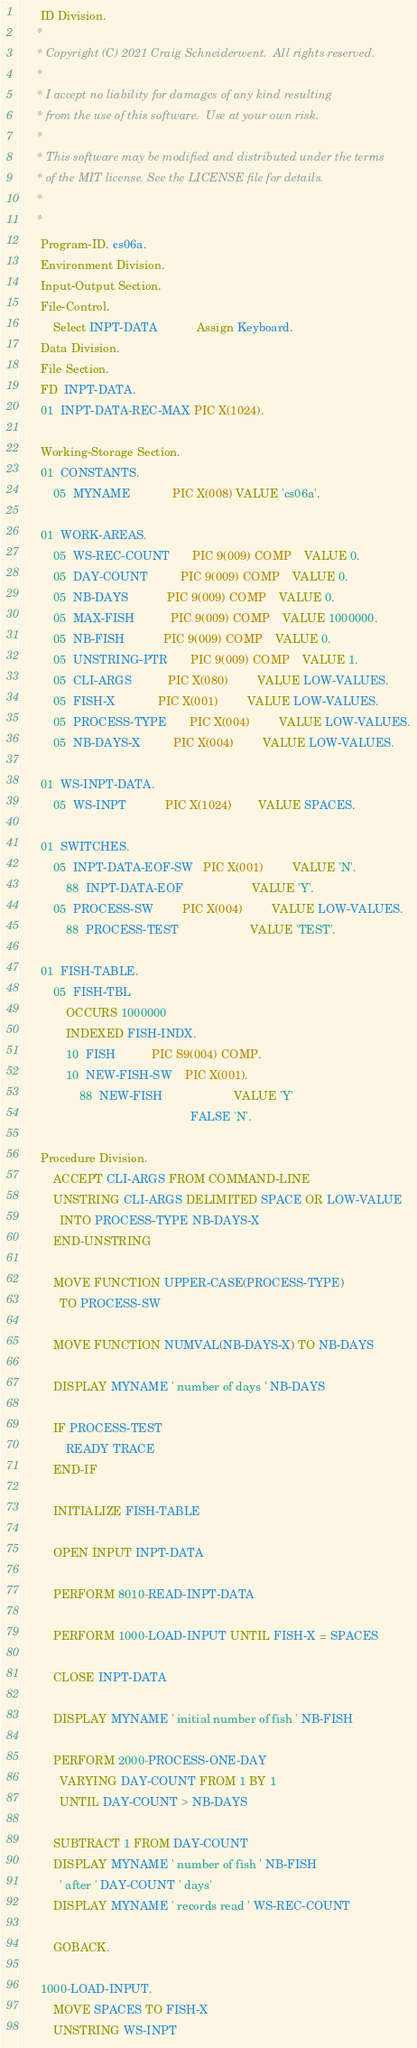Convert code to text. <code><loc_0><loc_0><loc_500><loc_500><_COBOL_>       ID Division.
      * 
      * Copyright (C) 2021 Craig Schneiderwent.  All rights reserved.
      * 
      * I accept no liability for damages of any kind resulting 
      * from the use of this software.  Use at your own risk.
      *
      * This software may be modified and distributed under the terms
      * of the MIT license. See the LICENSE file for details.
      *
      *
       Program-ID. cs06a.
       Environment Division.
       Input-Output Section.
       File-Control.
           Select INPT-DATA            Assign Keyboard.
       Data Division.
       File Section.
       FD  INPT-DATA.
       01  INPT-DATA-REC-MAX PIC X(1024).

       Working-Storage Section.
       01  CONSTANTS.
           05  MYNAME             PIC X(008) VALUE 'cs06a'.

       01  WORK-AREAS.
           05  WS-REC-COUNT       PIC 9(009) COMP    VALUE 0.
           05  DAY-COUNT          PIC 9(009) COMP    VALUE 0.
           05  NB-DAYS            PIC 9(009) COMP    VALUE 0.
           05  MAX-FISH           PIC 9(009) COMP    VALUE 1000000.
           05  NB-FISH            PIC 9(009) COMP    VALUE 0.
           05  UNSTRING-PTR       PIC 9(009) COMP    VALUE 1.
           05  CLI-ARGS           PIC X(080)         VALUE LOW-VALUES.
           05  FISH-X             PIC X(001)         VALUE LOW-VALUES.
           05  PROCESS-TYPE       PIC X(004)         VALUE LOW-VALUES.
           05  NB-DAYS-X          PIC X(004)         VALUE LOW-VALUES.

       01  WS-INPT-DATA.
           05  WS-INPT            PIC X(1024)        VALUE SPACES.

       01  SWITCHES.
           05  INPT-DATA-EOF-SW   PIC X(001)         VALUE 'N'.
               88  INPT-DATA-EOF                     VALUE 'Y'.
           05  PROCESS-SW         PIC X(004)         VALUE LOW-VALUES.
               88  PROCESS-TEST                      VALUE 'TEST'.

       01  FISH-TABLE.
           05  FISH-TBL
               OCCURS 1000000
               INDEXED FISH-INDX.
               10  FISH           PIC S9(004) COMP.
               10  NEW-FISH-SW    PIC X(001).
                   88  NEW-FISH                      VALUE 'Y'
                                                     FALSE 'N'.

       Procedure Division.
           ACCEPT CLI-ARGS FROM COMMAND-LINE
           UNSTRING CLI-ARGS DELIMITED SPACE OR LOW-VALUE
             INTO PROCESS-TYPE NB-DAYS-X
           END-UNSTRING

           MOVE FUNCTION UPPER-CASE(PROCESS-TYPE)
             TO PROCESS-SW

           MOVE FUNCTION NUMVAL(NB-DAYS-X) TO NB-DAYS

           DISPLAY MYNAME ' number of days ' NB-DAYS

           IF PROCESS-TEST
               READY TRACE
           END-IF

           INITIALIZE FISH-TABLE

           OPEN INPUT INPT-DATA

           PERFORM 8010-READ-INPT-DATA

           PERFORM 1000-LOAD-INPUT UNTIL FISH-X = SPACES

           CLOSE INPT-DATA

           DISPLAY MYNAME ' initial number of fish ' NB-FISH

           PERFORM 2000-PROCESS-ONE-DAY
             VARYING DAY-COUNT FROM 1 BY 1
             UNTIL DAY-COUNT > NB-DAYS

           SUBTRACT 1 FROM DAY-COUNT
           DISPLAY MYNAME ' number of fish ' NB-FISH
             ' after ' DAY-COUNT ' days'
           DISPLAY MYNAME ' records read ' WS-REC-COUNT

           GOBACK.

       1000-LOAD-INPUT.
           MOVE SPACES TO FISH-X
           UNSTRING WS-INPT</code> 